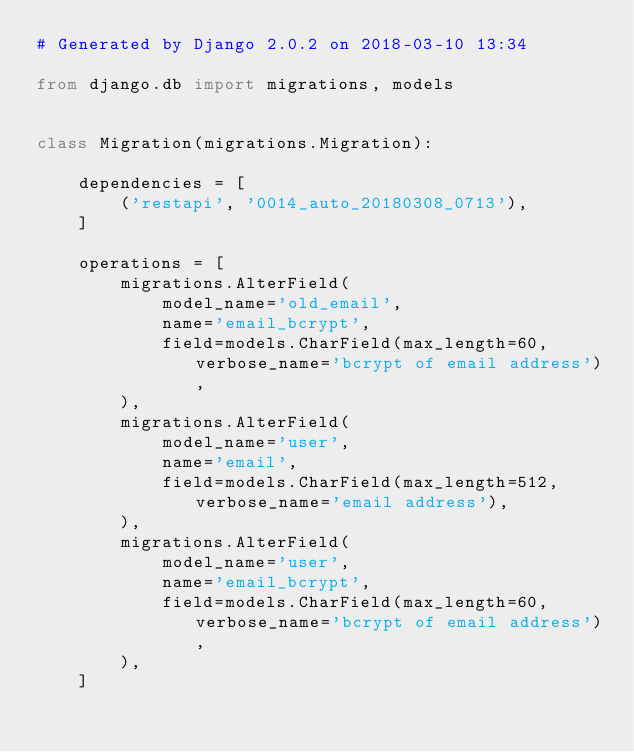<code> <loc_0><loc_0><loc_500><loc_500><_Python_># Generated by Django 2.0.2 on 2018-03-10 13:34

from django.db import migrations, models


class Migration(migrations.Migration):

    dependencies = [
        ('restapi', '0014_auto_20180308_0713'),
    ]

    operations = [
        migrations.AlterField(
            model_name='old_email',
            name='email_bcrypt',
            field=models.CharField(max_length=60, verbose_name='bcrypt of email address'),
        ),
        migrations.AlterField(
            model_name='user',
            name='email',
            field=models.CharField(max_length=512, verbose_name='email address'),
        ),
        migrations.AlterField(
            model_name='user',
            name='email_bcrypt',
            field=models.CharField(max_length=60, verbose_name='bcrypt of email address'),
        ),
    ]
</code> 